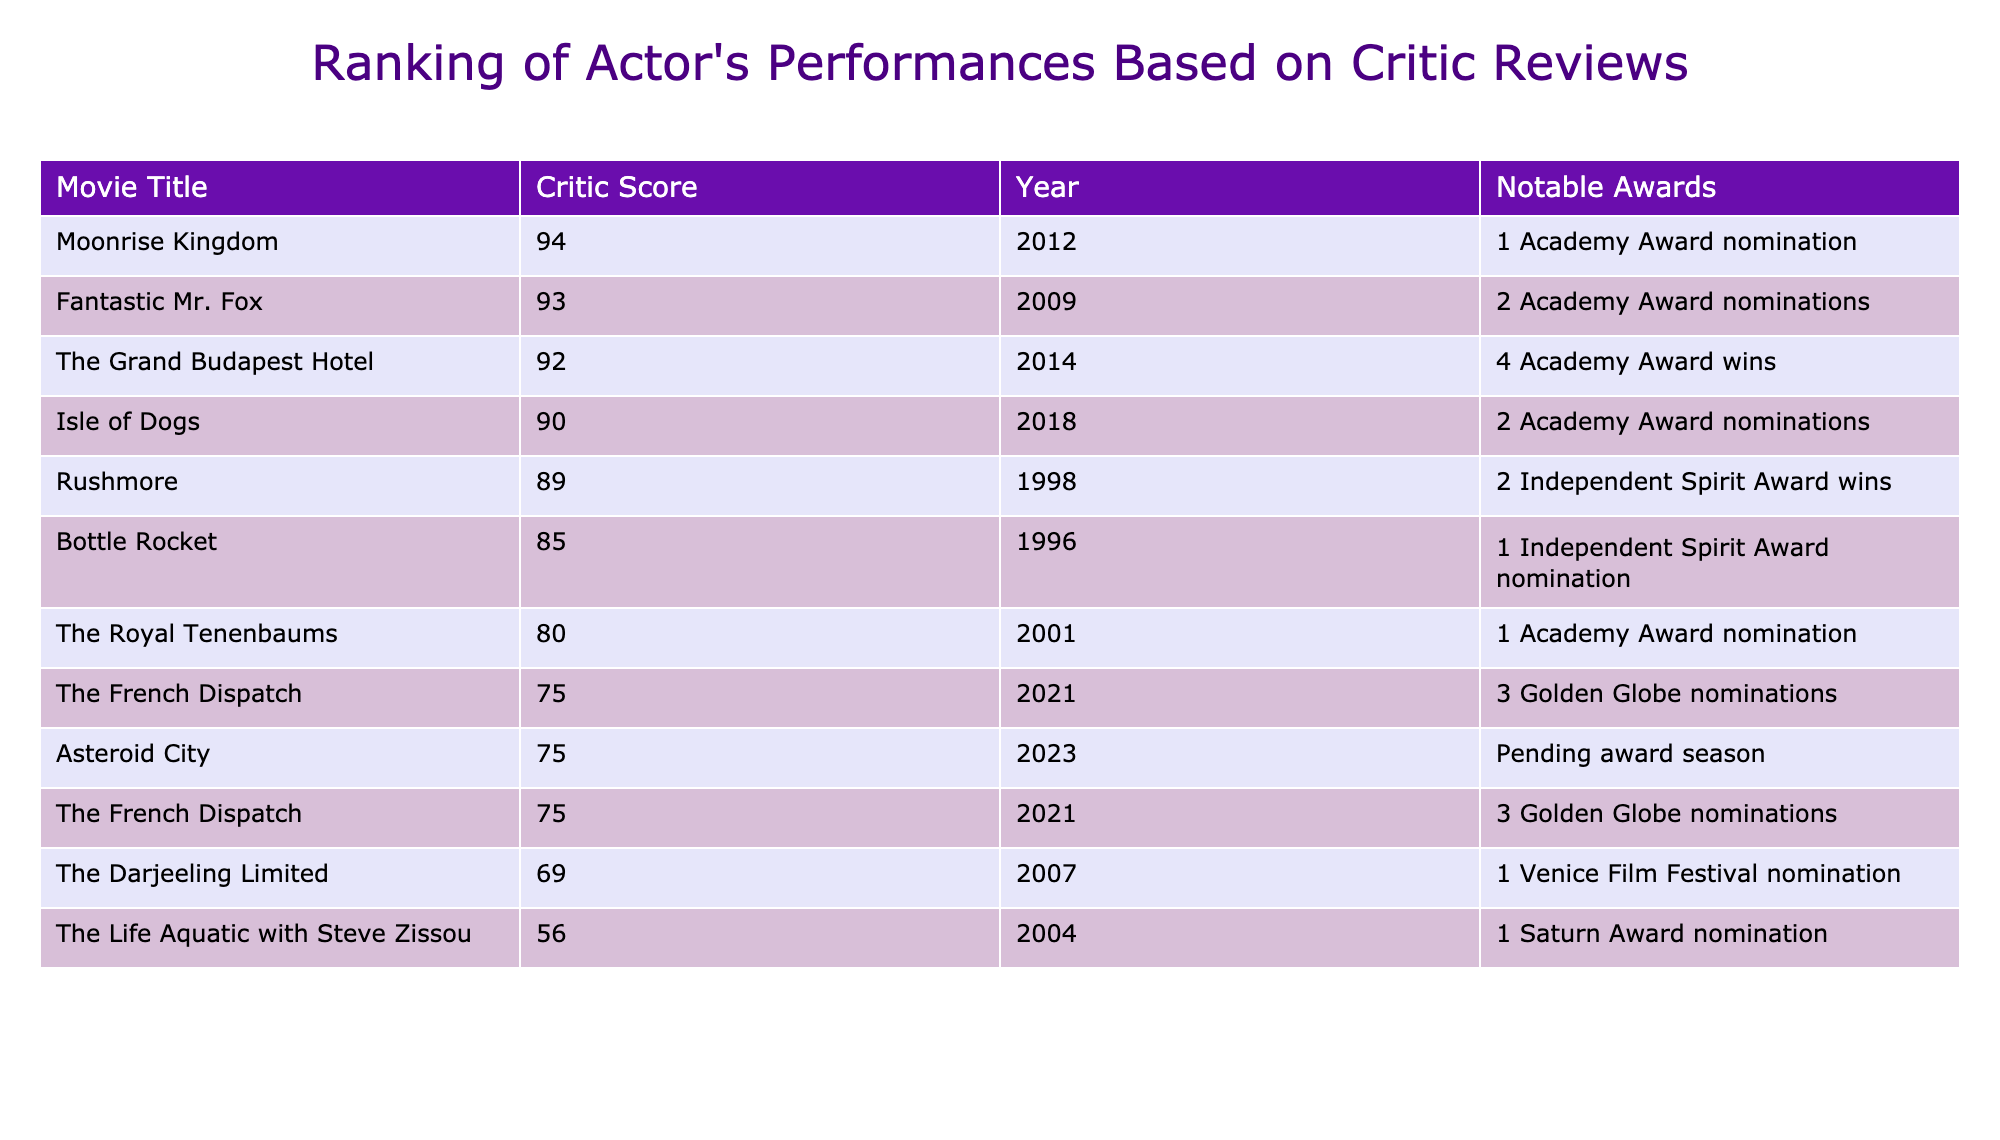What is the highest critic score among the movies listed? The table lists the critic scores of various movies. The highest score is 94, associated with "Moonrise Kingdom."
Answer: 94 Which movie won the most notable awards? "The Grand Budapest Hotel" won the most notable awards with 4 Academy Award wins, as reflected in the "Notable Awards" column.
Answer: The Grand Budapest Hotel What is the average critic score of all the movies? The total critic scores are (92 + 93 + 75 + 80 + 94 + 90 + 56 + 89 + 69 + 85 + 75) =  1,017. There are 11 movies, so the average is 1,017 / 11 ≈ 92.52.
Answer: Approximately 92.52 How many movies have a critic score below 70? The movies with scores below 70 are "The Life Aquatic with Steve Zissou" (56) and "The Darjeeling Limited" (69), making a total of 2 movies.
Answer: 2 Is "Bottle Rocket" nominated for any notable awards? According to the table, "Bottle Rocket" received 1 Independent Spirit Award nomination, confirming that it is nominated.
Answer: Yes Which movie released in 2021 has the same critic score as "Asteroid City"? "The French Dispatch," also released in 2021, shares the same critic score of 75 with "Asteroid City."
Answer: The French Dispatch What is the difference in critic scores between the highest and lowest-rated movies? The highest-rated movie is "Moonrise Kingdom" with a score of 94, and the lowest is "The Life Aquatic with Steve Zissou" with a score of 56. The difference is 94 - 56 = 38.
Answer: 38 Are there any movies listed from the year 2000 or earlier? Yes, the movies from the year 2000 or earlier include "Rushmore" (1998), "Bottle Rocket" (1996), "The Royal Tenenbaums" (2001), and "The Life Aquatic with Steve Zissou" (2004).
Answer: Yes How many movies have achieved a critic score of 80 or higher? The movies with scores of 80 or higher are "The Grand Budapest Hotel," "Fantastic Mr. Fox," "Moonrise Kingdom," "Isle of Dogs," "Rushmore," and "Bottle Rocket," totaling 6 movies.
Answer: 6 Which two movies from 2012 and 2018 have Oscar nominations as their notable awards? "Moonrise Kingdom" from 2012 has 1 Academy Award nomination, and "Isle of Dogs" from 2018 has 2 Academy Award nominations.
Answer: Moonrise Kingdom and Isle of Dogs 